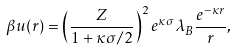Convert formula to latex. <formula><loc_0><loc_0><loc_500><loc_500>\beta u ( r ) = \left ( \frac { Z } { 1 + \kappa \sigma / 2 } \right ) ^ { 2 } e ^ { \kappa \sigma } \lambda _ { B } \frac { e ^ { - \kappa r } } { r } ,</formula> 